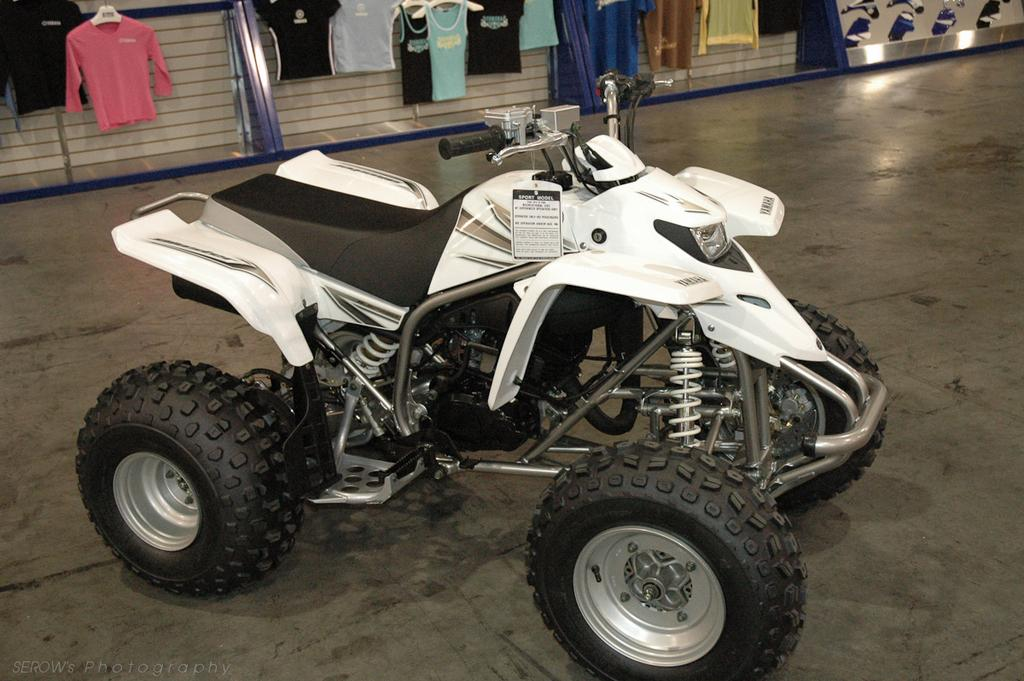What is the color of the vehicle in the image? The vehicle in the image is white. What can be seen in the background of the image? There are clothes in the background of the image. Where is the text or image located in the image? The text or image is in the left bottom corner of the image. How many cherries are on the pan in the image? There is no pan or cherries present in the image. 